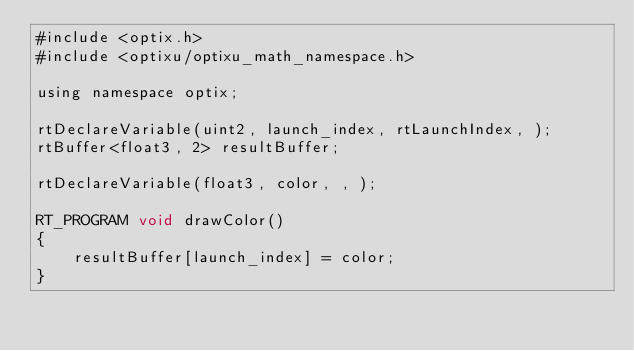<code> <loc_0><loc_0><loc_500><loc_500><_Cuda_>#include <optix.h>
#include <optixu/optixu_math_namespace.h>

using namespace optix;

rtDeclareVariable(uint2, launch_index, rtLaunchIndex, );
rtBuffer<float3, 2> resultBuffer;

rtDeclareVariable(float3, color, , );

RT_PROGRAM void drawColor()
{
    resultBuffer[launch_index] = color;
}
</code> 